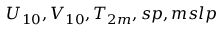Convert formula to latex. <formula><loc_0><loc_0><loc_500><loc_500>U _ { 1 0 } , V _ { 1 0 } , T _ { 2 m } , s p , m s l p</formula> 